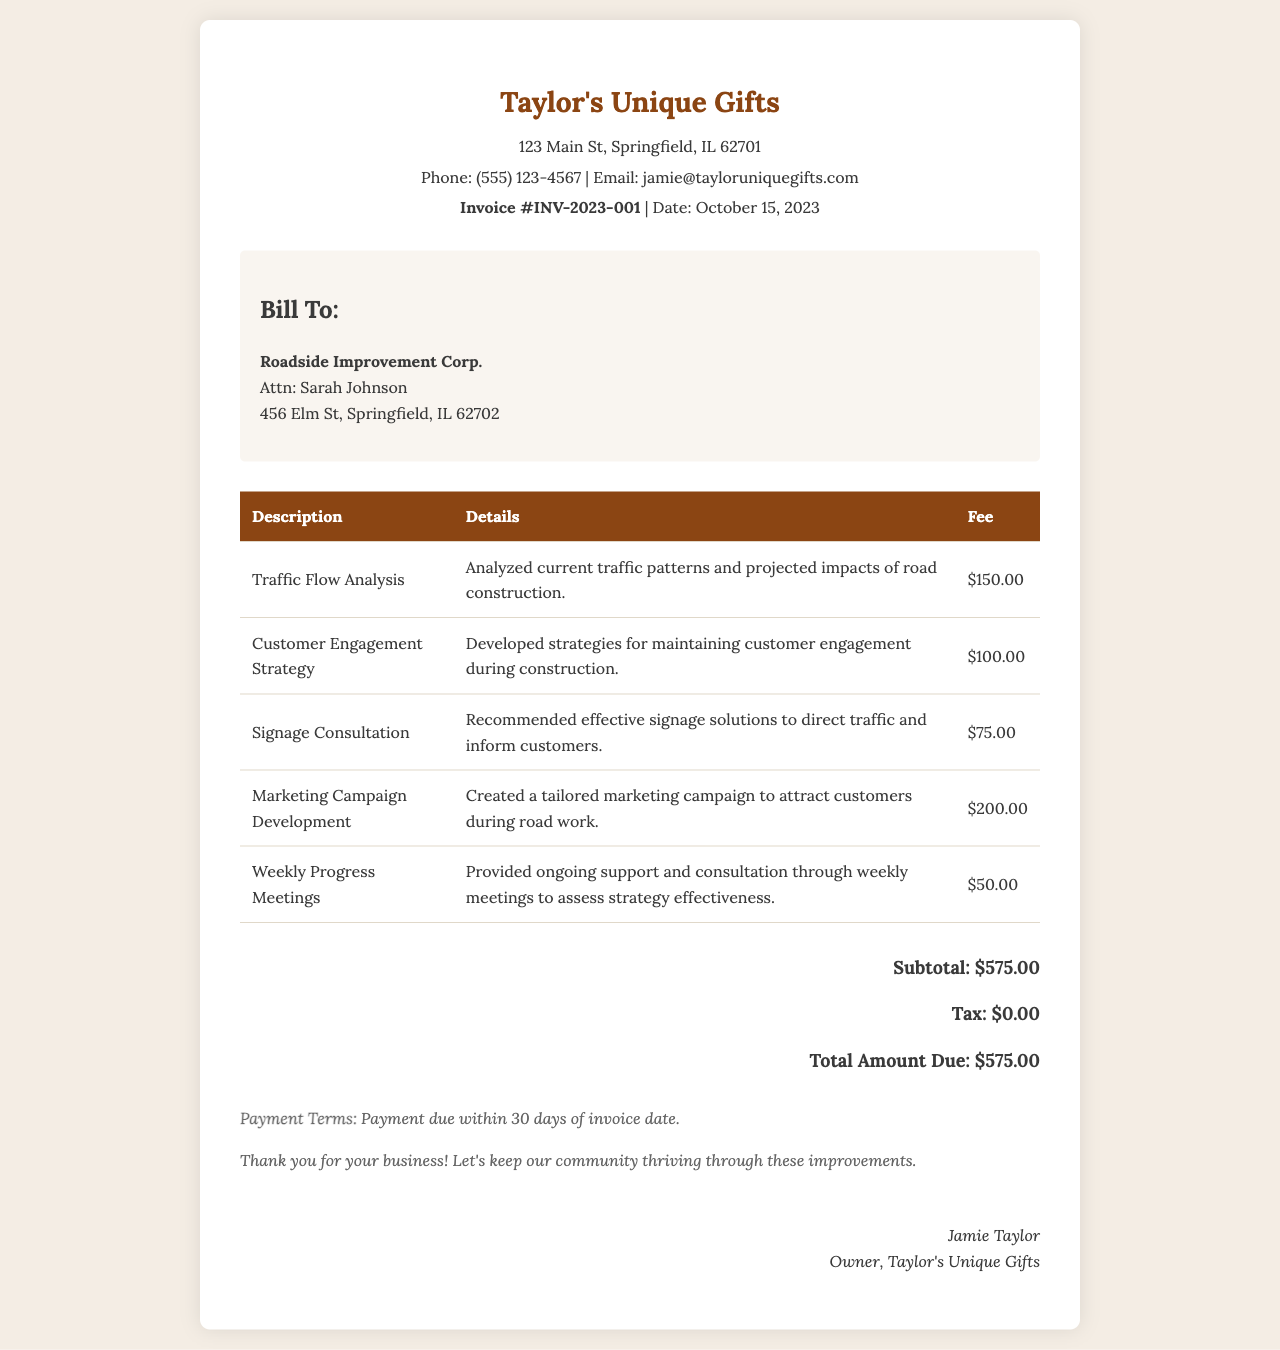what is the invoice number? The invoice number is provided in the header of the document as a unique identifier.
Answer: INV-2023-001 who is the client? The client details are listed under the "Bill To" section of the document.
Answer: Roadside Improvement Corp what is the total amount due? The total amount due is calculated as the sum of the fees listed in the invoice.
Answer: $575.00 what is the fee for Traffic Flow Analysis? This fee is mentioned in the itemized list of services provided in the invoice.
Answer: $150.00 how many items are listed in the table? The number of items is determined by counting the rows in the services table, excluding the header.
Answer: 5 what is the date of the invoice? The date is specified in the header of the document, indicating when the invoice was issued.
Answer: October 15, 2023 what is the payment term? The payment term outlines the conditions for when payment should be made, mentioned at the bottom of the document.
Answer: Payment due within 30 days of invoice date who is the owner of the consulting firm? The owner's name appears at the end of the document alongside their title.
Answer: Jamie Taylor 